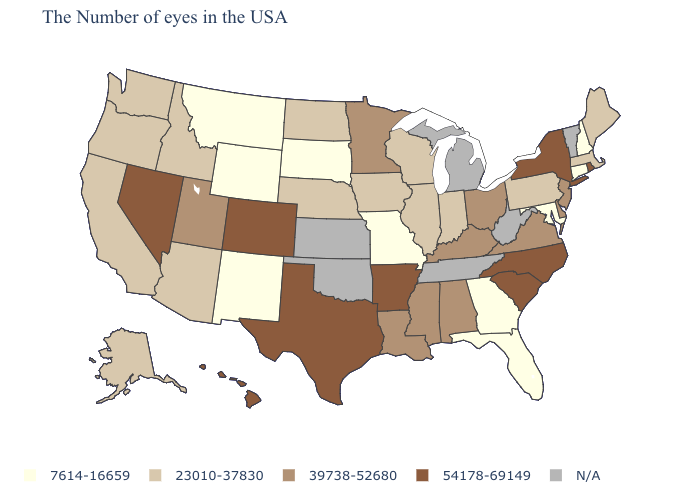Does Colorado have the highest value in the USA?
Be succinct. Yes. Name the states that have a value in the range 54178-69149?
Keep it brief. Rhode Island, New York, North Carolina, South Carolina, Arkansas, Texas, Colorado, Nevada, Hawaii. Among the states that border Massachusetts , does Rhode Island have the highest value?
Keep it brief. Yes. Which states hav the highest value in the Northeast?
Give a very brief answer. Rhode Island, New York. Name the states that have a value in the range 39738-52680?
Give a very brief answer. New Jersey, Delaware, Virginia, Ohio, Kentucky, Alabama, Mississippi, Louisiana, Minnesota, Utah. What is the highest value in the West ?
Quick response, please. 54178-69149. What is the highest value in states that border New Jersey?
Concise answer only. 54178-69149. What is the lowest value in states that border Missouri?
Short answer required. 23010-37830. What is the lowest value in the MidWest?
Be succinct. 7614-16659. Name the states that have a value in the range 54178-69149?
Keep it brief. Rhode Island, New York, North Carolina, South Carolina, Arkansas, Texas, Colorado, Nevada, Hawaii. Does New York have the highest value in the USA?
Concise answer only. Yes. Name the states that have a value in the range 7614-16659?
Quick response, please. New Hampshire, Connecticut, Maryland, Florida, Georgia, Missouri, South Dakota, Wyoming, New Mexico, Montana. What is the value of Nebraska?
Answer briefly. 23010-37830. Does New Jersey have the lowest value in the Northeast?
Answer briefly. No. What is the highest value in states that border Arkansas?
Answer briefly. 54178-69149. 